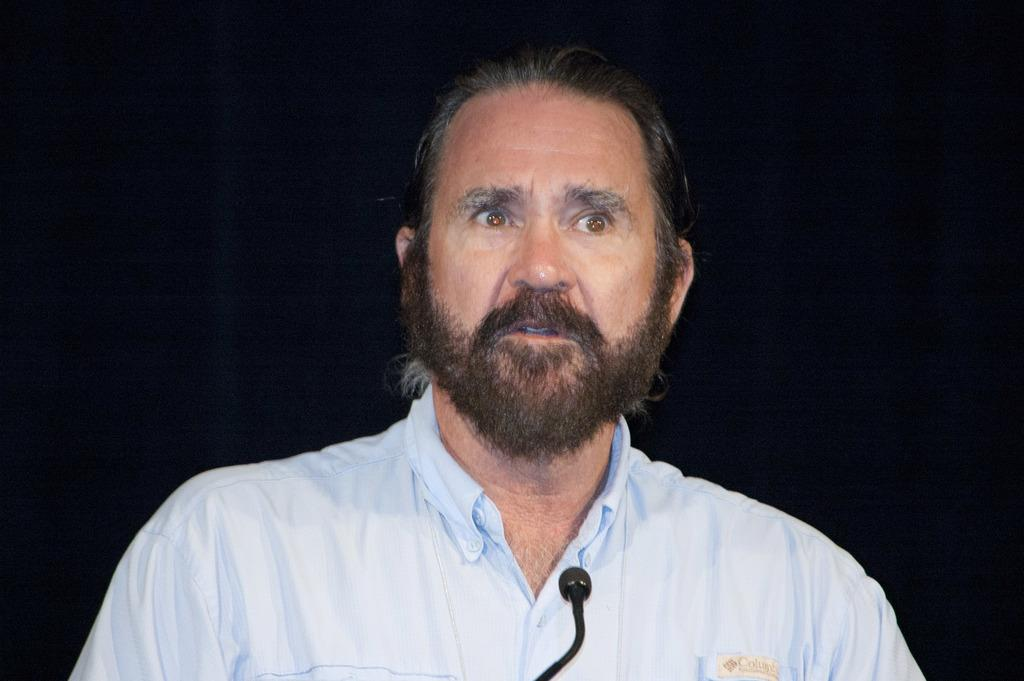Who or what is the main subject in the center of the image? There is a person in the center of the image. What object is in the front of the image? There is a microphone (mic) in the front of the image. How would you describe the background of the image? The background of the image is dark. How many passengers are visible in the image? There are no passengers present in the image; it features a person and a microphone. What type of grip does the person have on the middle of the image? There is no mention of a grip or any object being held in the middle of the image; it only shows a person and a microphone. 